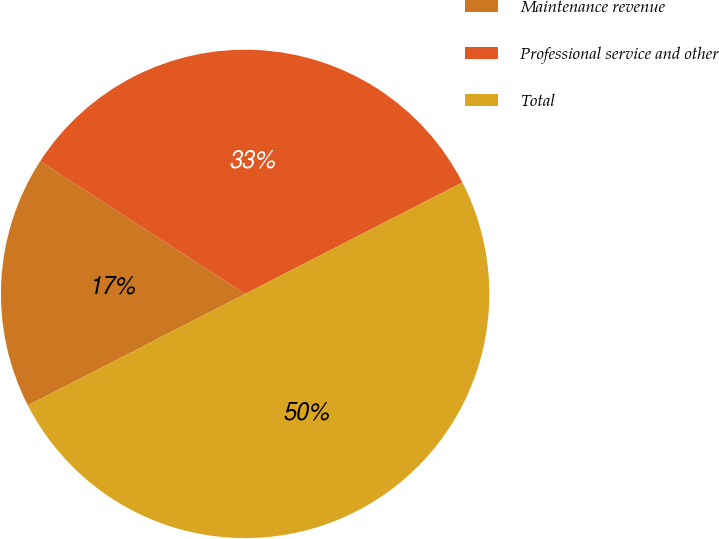<chart> <loc_0><loc_0><loc_500><loc_500><pie_chart><fcel>Maintenance revenue<fcel>Professional service and other<fcel>Total<nl><fcel>16.69%<fcel>33.31%<fcel>50.0%<nl></chart> 